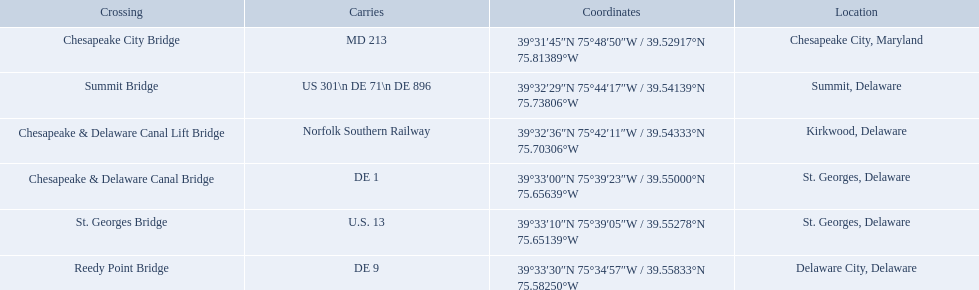What are the names of the major crossings for the chesapeake and delaware canal? Chesapeake City Bridge, Summit Bridge, Chesapeake & Delaware Canal Lift Bridge, Chesapeake & Delaware Canal Bridge, St. Georges Bridge, Reedy Point Bridge. What routes are carried by these crossings? MD 213, US 301\n DE 71\n DE 896, Norfolk Southern Railway, DE 1, U.S. 13, DE 9. Write the full table. {'header': ['Crossing', 'Carries', 'Coordinates', 'Location'], 'rows': [['Chesapeake City Bridge', 'MD 213', '39°31′45″N 75°48′50″W\ufeff / \ufeff39.52917°N 75.81389°W', 'Chesapeake City, Maryland'], ['Summit Bridge', 'US 301\\n DE 71\\n DE 896', '39°32′29″N 75°44′17″W\ufeff / \ufeff39.54139°N 75.73806°W', 'Summit, Delaware'], ['Chesapeake & Delaware Canal Lift Bridge', 'Norfolk Southern Railway', '39°32′36″N 75°42′11″W\ufeff / \ufeff39.54333°N 75.70306°W', 'Kirkwood, Delaware'], ['Chesapeake & Delaware Canal Bridge', 'DE 1', '39°33′00″N 75°39′23″W\ufeff / \ufeff39.55000°N 75.65639°W', 'St.\xa0Georges, Delaware'], ['St.\xa0Georges Bridge', 'U.S.\xa013', '39°33′10″N 75°39′05″W\ufeff / \ufeff39.55278°N 75.65139°W', 'St.\xa0Georges, Delaware'], ['Reedy Point Bridge', 'DE\xa09', '39°33′30″N 75°34′57″W\ufeff / \ufeff39.55833°N 75.58250°W', 'Delaware City, Delaware']]} Which of those routes is comprised of more than one route? US 301\n DE 71\n DE 896. Which crossing carries those routes? Summit Bridge. 